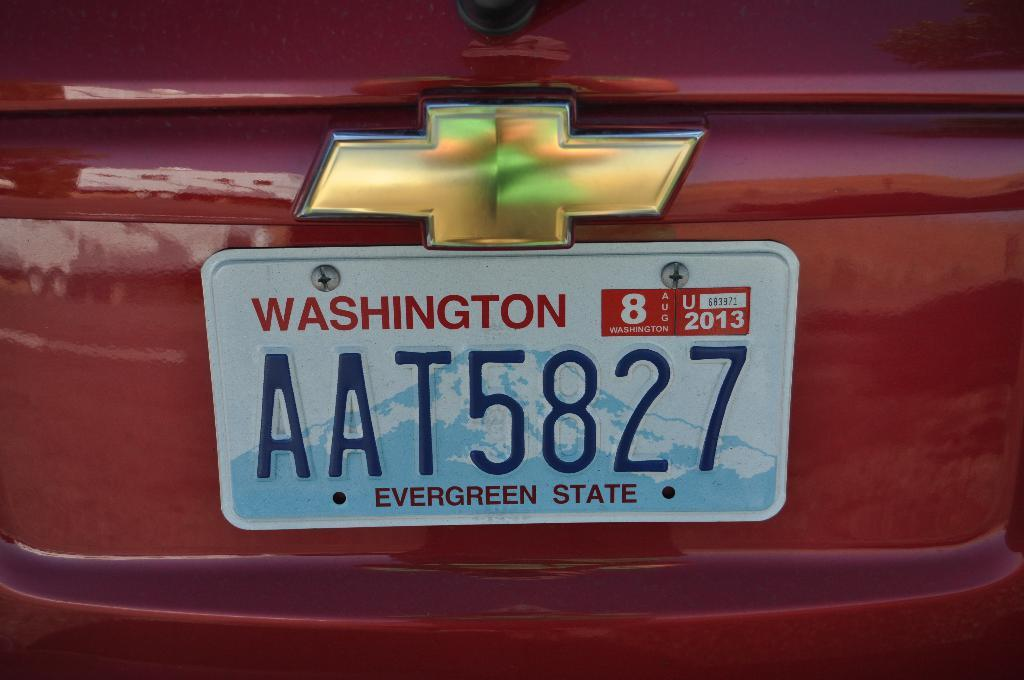<image>
Create a compact narrative representing the image presented. Red Chevy with the license plate "AAT5827" in the back. 